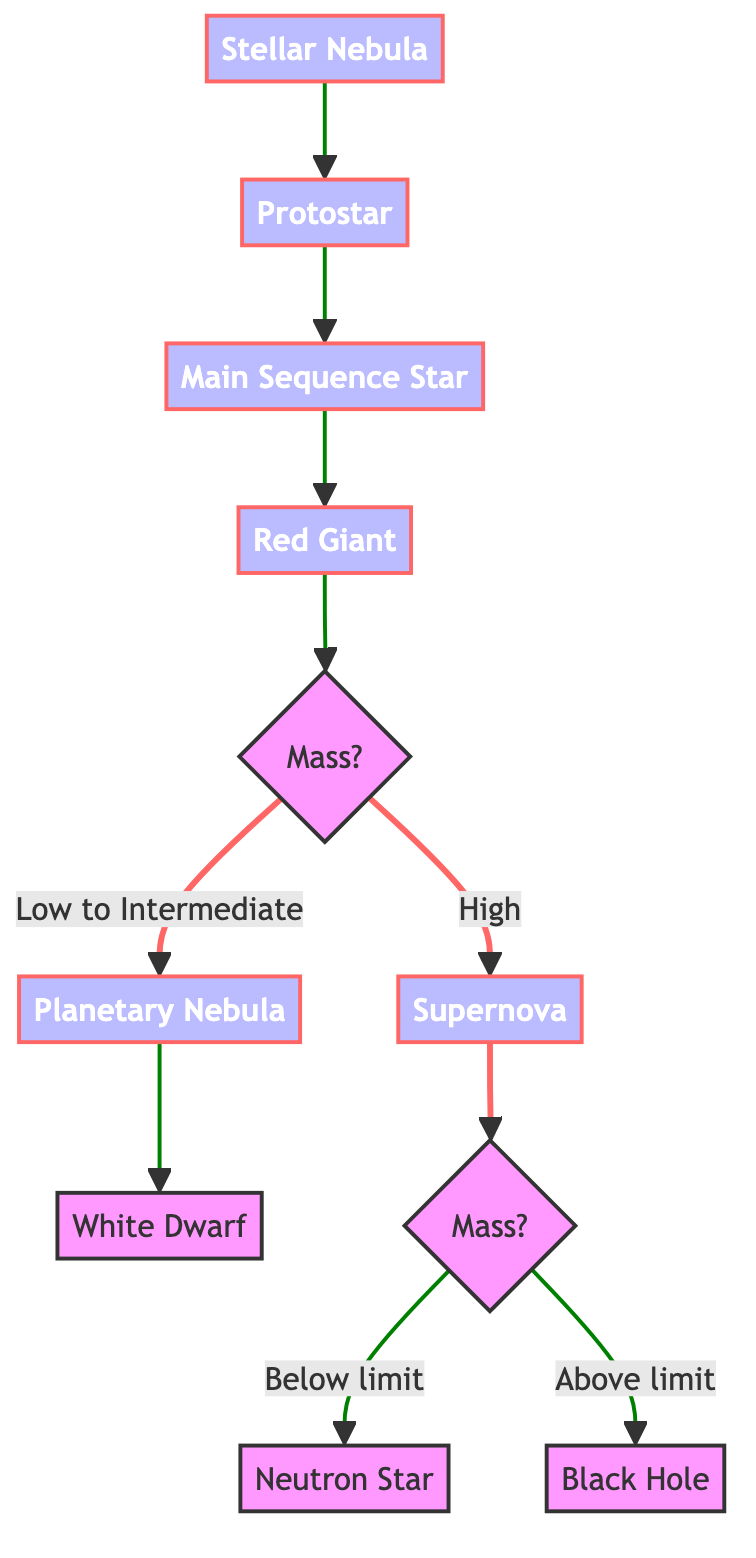What is the first stage in the star lifecycle? The diagram shows an arrow pointing from "Stellar Nebula" to "Protostar," indicating that "Stellar Nebula" is the first stage where the star begins to form.
Answer: Stellar Nebula What happens after a protostar? The flow diagram shows the progression from "Protostar" to "Main Sequence Star," indicating that following the protostar stage, the star enters the main sequence phase.
Answer: Main Sequence Star How many final outcomes are there for high-mass stars? The diagram illustrates two potential outcomes for high-mass stars after the "Supernova" stage: "Neutron Star" and "Black Hole." Therefore, there are two final outcomes.
Answer: Two What process occurs during the Red Giant phase? The diagram shows that during the "Red Giant" phase, the core contracts while outer layers expand, and helium fusion starts. This process indicates a significant change in the star's structure and fusion process.
Answer: Core contracts and helium fusion starts What determines whether a star forms a Neutron Star or a Black Hole? The diagram presents a decision point after the "Supernova" indicating that the outcome depends on the mass of the remaining core, specifically whether it is below or above the Tolman–Oppenheimer–Volkoff limit. This relation dictates the definitive outcome between a Neutron Star or a Black Hole.
Answer: Mass of remaining core What type of nebula forms from low to intermediate mass stars? The diagram specifies that "Planetary Nebula" is formed from low to intermediate mass stars after the "Red Giant" stage, specifically indicating the fate of these stars post-expansion and core contraction.
Answer: Planetary Nebula Which element provides the necessary pressure in a Main Sequence Star? According to the diagram, in the "Main Sequence Star" phase, it is stated that hydrogen fusion provides the outward pressure needed to counteract gravitational collapse. Therefore, hydrogen is the element referenced.
Answer: Hydrogen At what stage does a star become unstable and explode? The diagram indicates that instability leads to a "Supernova," which occurs after the "Red Giant" stage for high-mass stars. This violent event marks the end of a massive star's lifecycle.
Answer: Supernova 